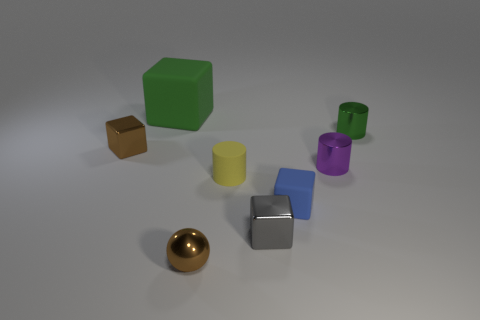How many other objects are the same size as the yellow cylinder?
Your response must be concise. 6. The tiny brown thing that is left of the metal thing that is in front of the small metallic block right of the brown ball is what shape?
Ensure brevity in your answer.  Cube. How many gray objects are either large spheres or small blocks?
Offer a terse response. 1. What number of tiny purple shiny cylinders are left of the matte block in front of the large matte thing?
Offer a very short reply. 0. Is there any other thing that is the same color as the metallic sphere?
Keep it short and to the point. Yes. The purple object that is the same material as the tiny green cylinder is what shape?
Offer a very short reply. Cylinder. Do the tiny sphere and the tiny matte block have the same color?
Provide a short and direct response. No. Is the green thing that is behind the green metal thing made of the same material as the tiny block behind the blue thing?
Provide a succinct answer. No. How many things are rubber cubes or brown metal things that are behind the yellow matte cylinder?
Offer a terse response. 3. Is there anything else that has the same material as the gray cube?
Keep it short and to the point. Yes. 